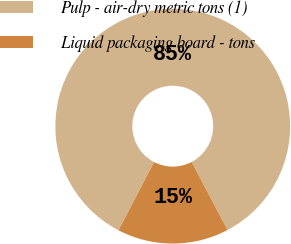Convert chart to OTSL. <chart><loc_0><loc_0><loc_500><loc_500><pie_chart><fcel>Pulp - air-dry metric tons (1)<fcel>Liquid packaging board - tons<nl><fcel>84.64%<fcel>15.36%<nl></chart> 